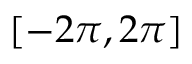<formula> <loc_0><loc_0><loc_500><loc_500>\left [ - 2 \pi , 2 \pi \right ]</formula> 